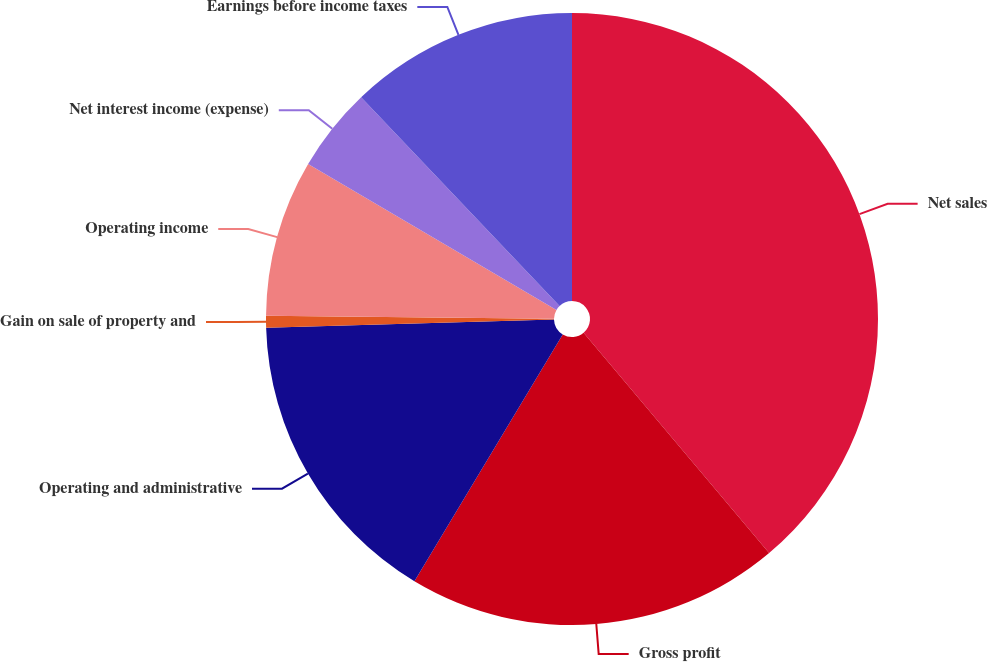<chart> <loc_0><loc_0><loc_500><loc_500><pie_chart><fcel>Net sales<fcel>Gross profit<fcel>Operating and administrative<fcel>Gain on sale of property and<fcel>Operating income<fcel>Net interest income (expense)<fcel>Earnings before income taxes<nl><fcel>38.86%<fcel>19.75%<fcel>15.93%<fcel>0.63%<fcel>8.28%<fcel>4.45%<fcel>12.1%<nl></chart> 